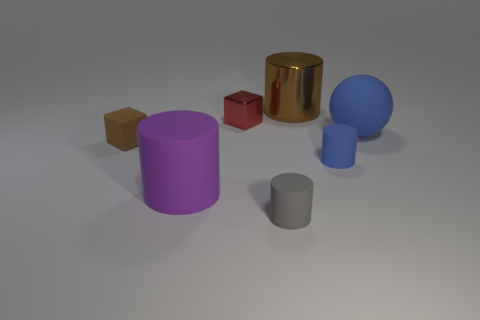Add 1 brown rubber blocks. How many objects exist? 8 Subtract all cylinders. How many objects are left? 3 Add 2 big rubber objects. How many big rubber objects exist? 4 Subtract 0 green balls. How many objects are left? 7 Subtract all big metal cylinders. Subtract all brown metal objects. How many objects are left? 5 Add 5 tiny red things. How many tiny red things are left? 6 